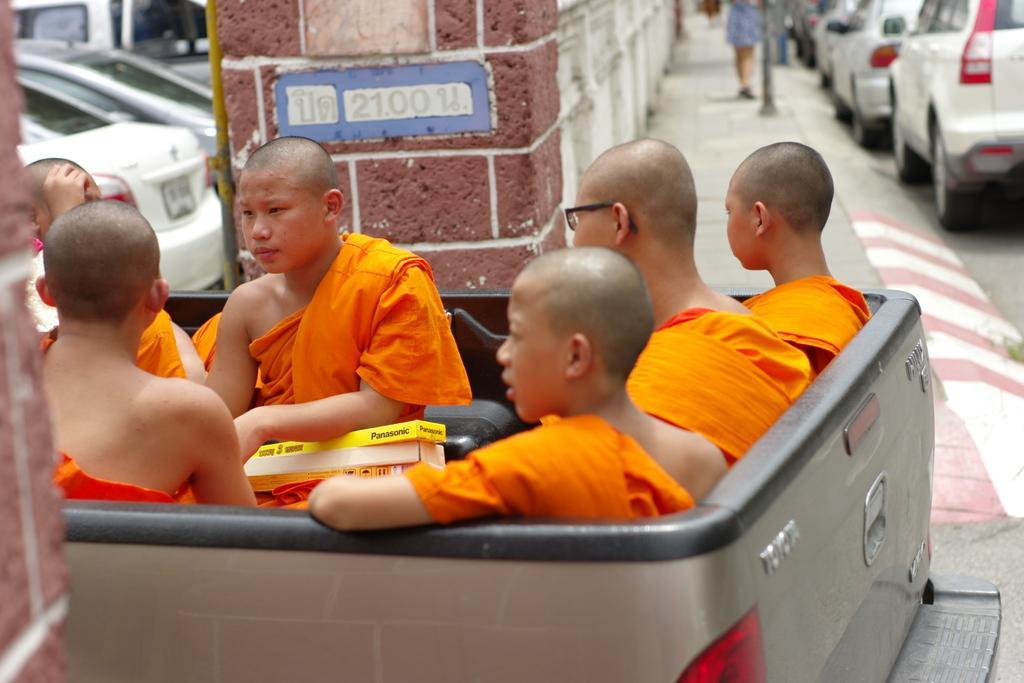Please provide a concise description of this image. In this image we can see a group of people sitting inside a truck. In that a child is holding some boxes. On the backside we can see a pillar, some cars parked aside, a wall and a woman walking on the footpath. 